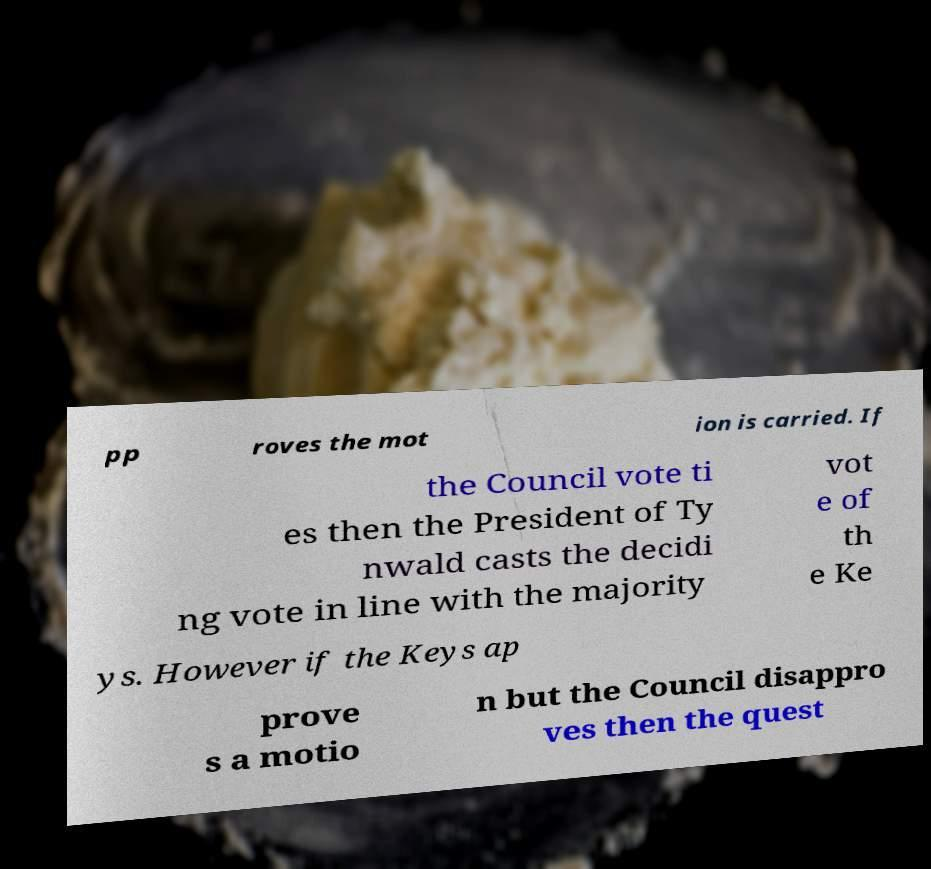Please read and relay the text visible in this image. What does it say? pp roves the mot ion is carried. If the Council vote ti es then the President of Ty nwald casts the decidi ng vote in line with the majority vot e of th e Ke ys. However if the Keys ap prove s a motio n but the Council disappro ves then the quest 